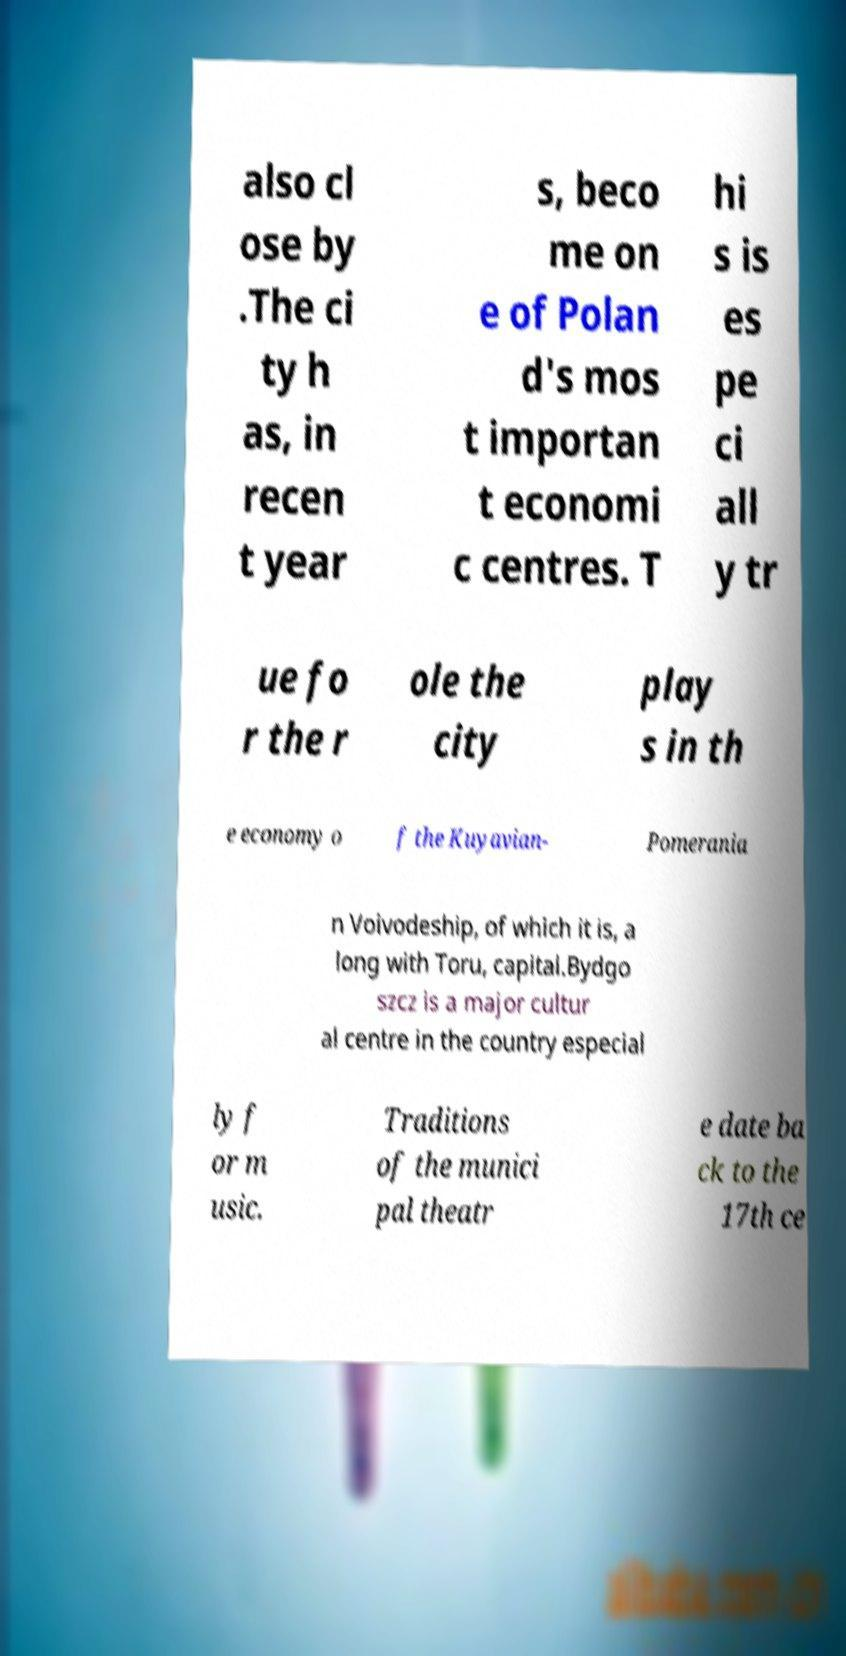For documentation purposes, I need the text within this image transcribed. Could you provide that? also cl ose by .The ci ty h as, in recen t year s, beco me on e of Polan d's mos t importan t economi c centres. T hi s is es pe ci all y tr ue fo r the r ole the city play s in th e economy o f the Kuyavian- Pomerania n Voivodeship, of which it is, a long with Toru, capital.Bydgo szcz is a major cultur al centre in the country especial ly f or m usic. Traditions of the munici pal theatr e date ba ck to the 17th ce 